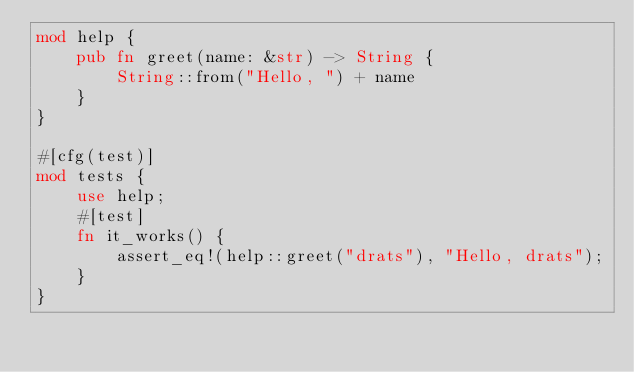<code> <loc_0><loc_0><loc_500><loc_500><_Rust_>mod help {
    pub fn greet(name: &str) -> String {
        String::from("Hello, ") + name
    }
}

#[cfg(test)]
mod tests {
    use help;
    #[test]
    fn it_works() {
        assert_eq!(help::greet("drats"), "Hello, drats");
    }
}
</code> 